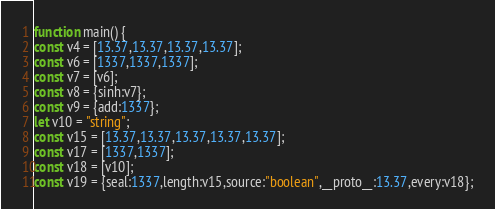<code> <loc_0><loc_0><loc_500><loc_500><_JavaScript_>function main() {
const v4 = [13.37,13.37,13.37,13.37];
const v6 = [1337,1337,1337];
const v7 = [v6];
const v8 = {sinh:v7};
const v9 = {add:1337};
let v10 = "string";
const v15 = [13.37,13.37,13.37,13.37,13.37];
const v17 = [1337,1337];
const v18 = [v10];
const v19 = {seal:1337,length:v15,source:"boolean",__proto__:13.37,every:v18};</code> 